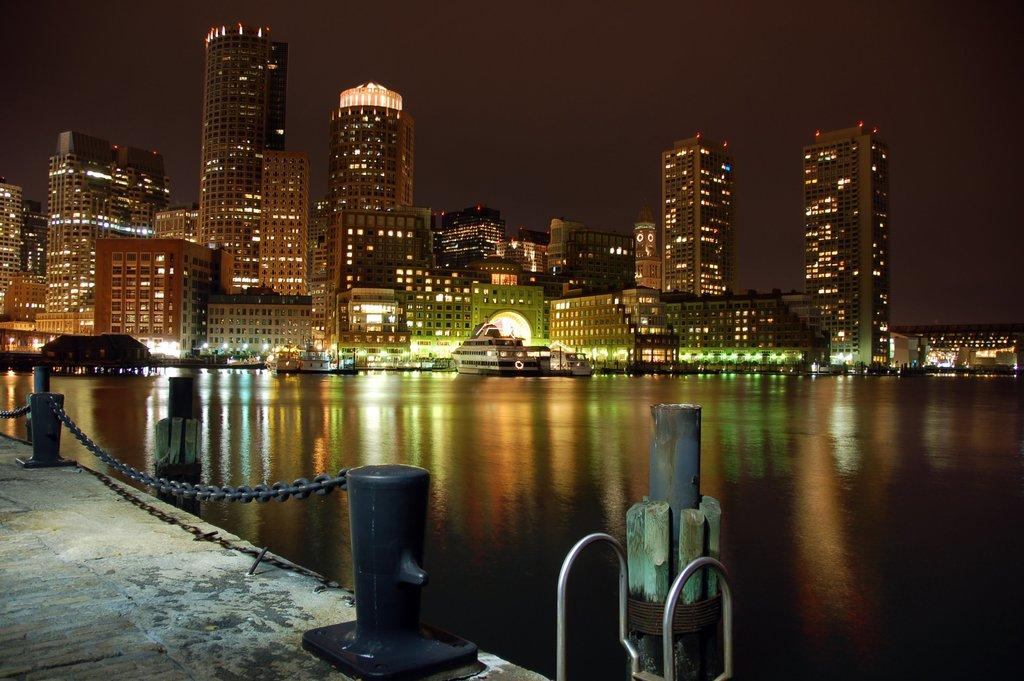What is located on the left side of the image? There is a floor on the left side of the image. What is placed on the floor? There is fencing on the floor. What can be seen in the background of the image? There are boats on the water and buildings with lights in the background of the image. What part of the natural environment is visible in the image? The sky is visible in the background of the image. What type of paper is being used to shock the company in the image? There is no paper or company present in the image, and therefore no such activity can be observed. 